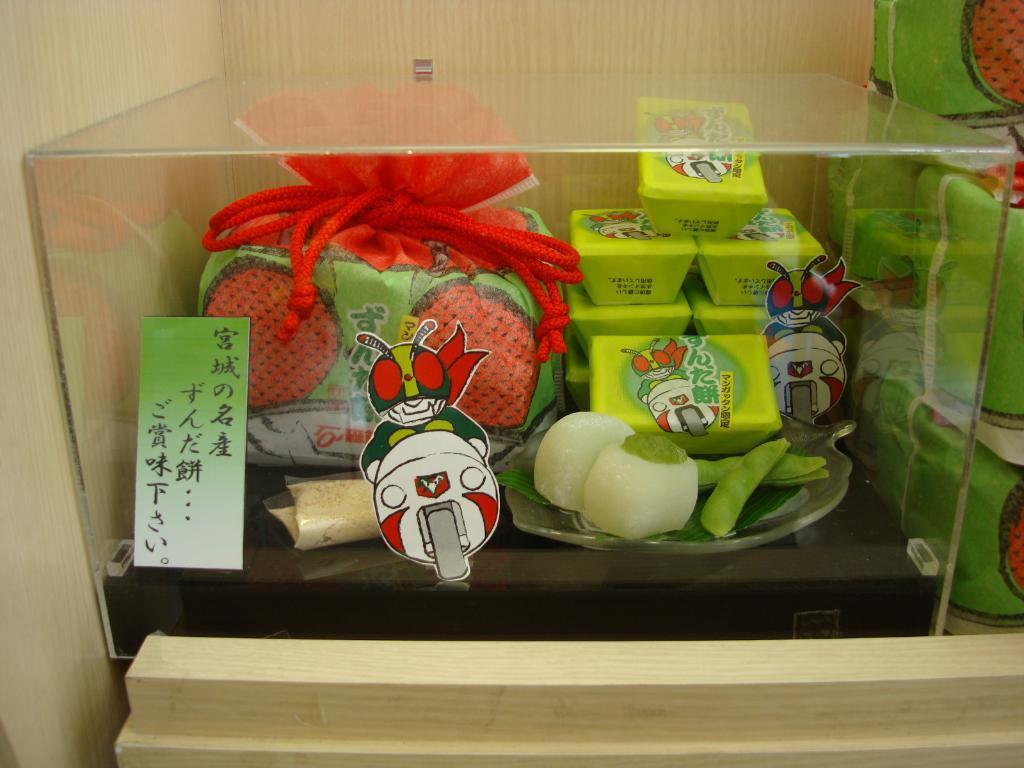In one or two sentences, can you explain what this image depicts? In this image I can see food items in a glass box. There are stickers on the glass box. In the right side of the image it looks like food packets or bags. 